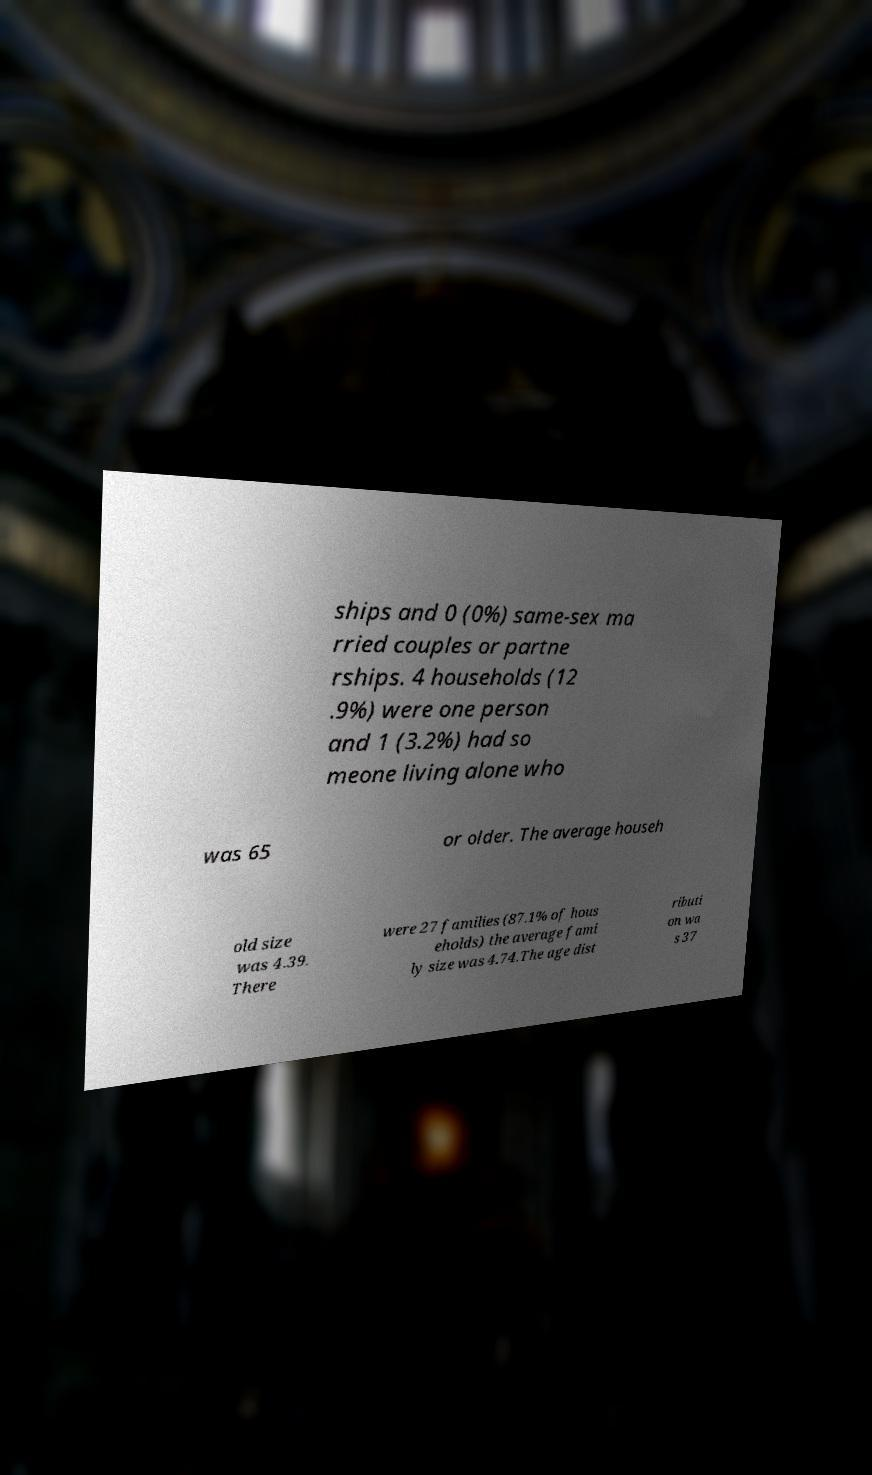Could you assist in decoding the text presented in this image and type it out clearly? ships and 0 (0%) same-sex ma rried couples or partne rships. 4 households (12 .9%) were one person and 1 (3.2%) had so meone living alone who was 65 or older. The average househ old size was 4.39. There were 27 families (87.1% of hous eholds) the average fami ly size was 4.74.The age dist ributi on wa s 37 